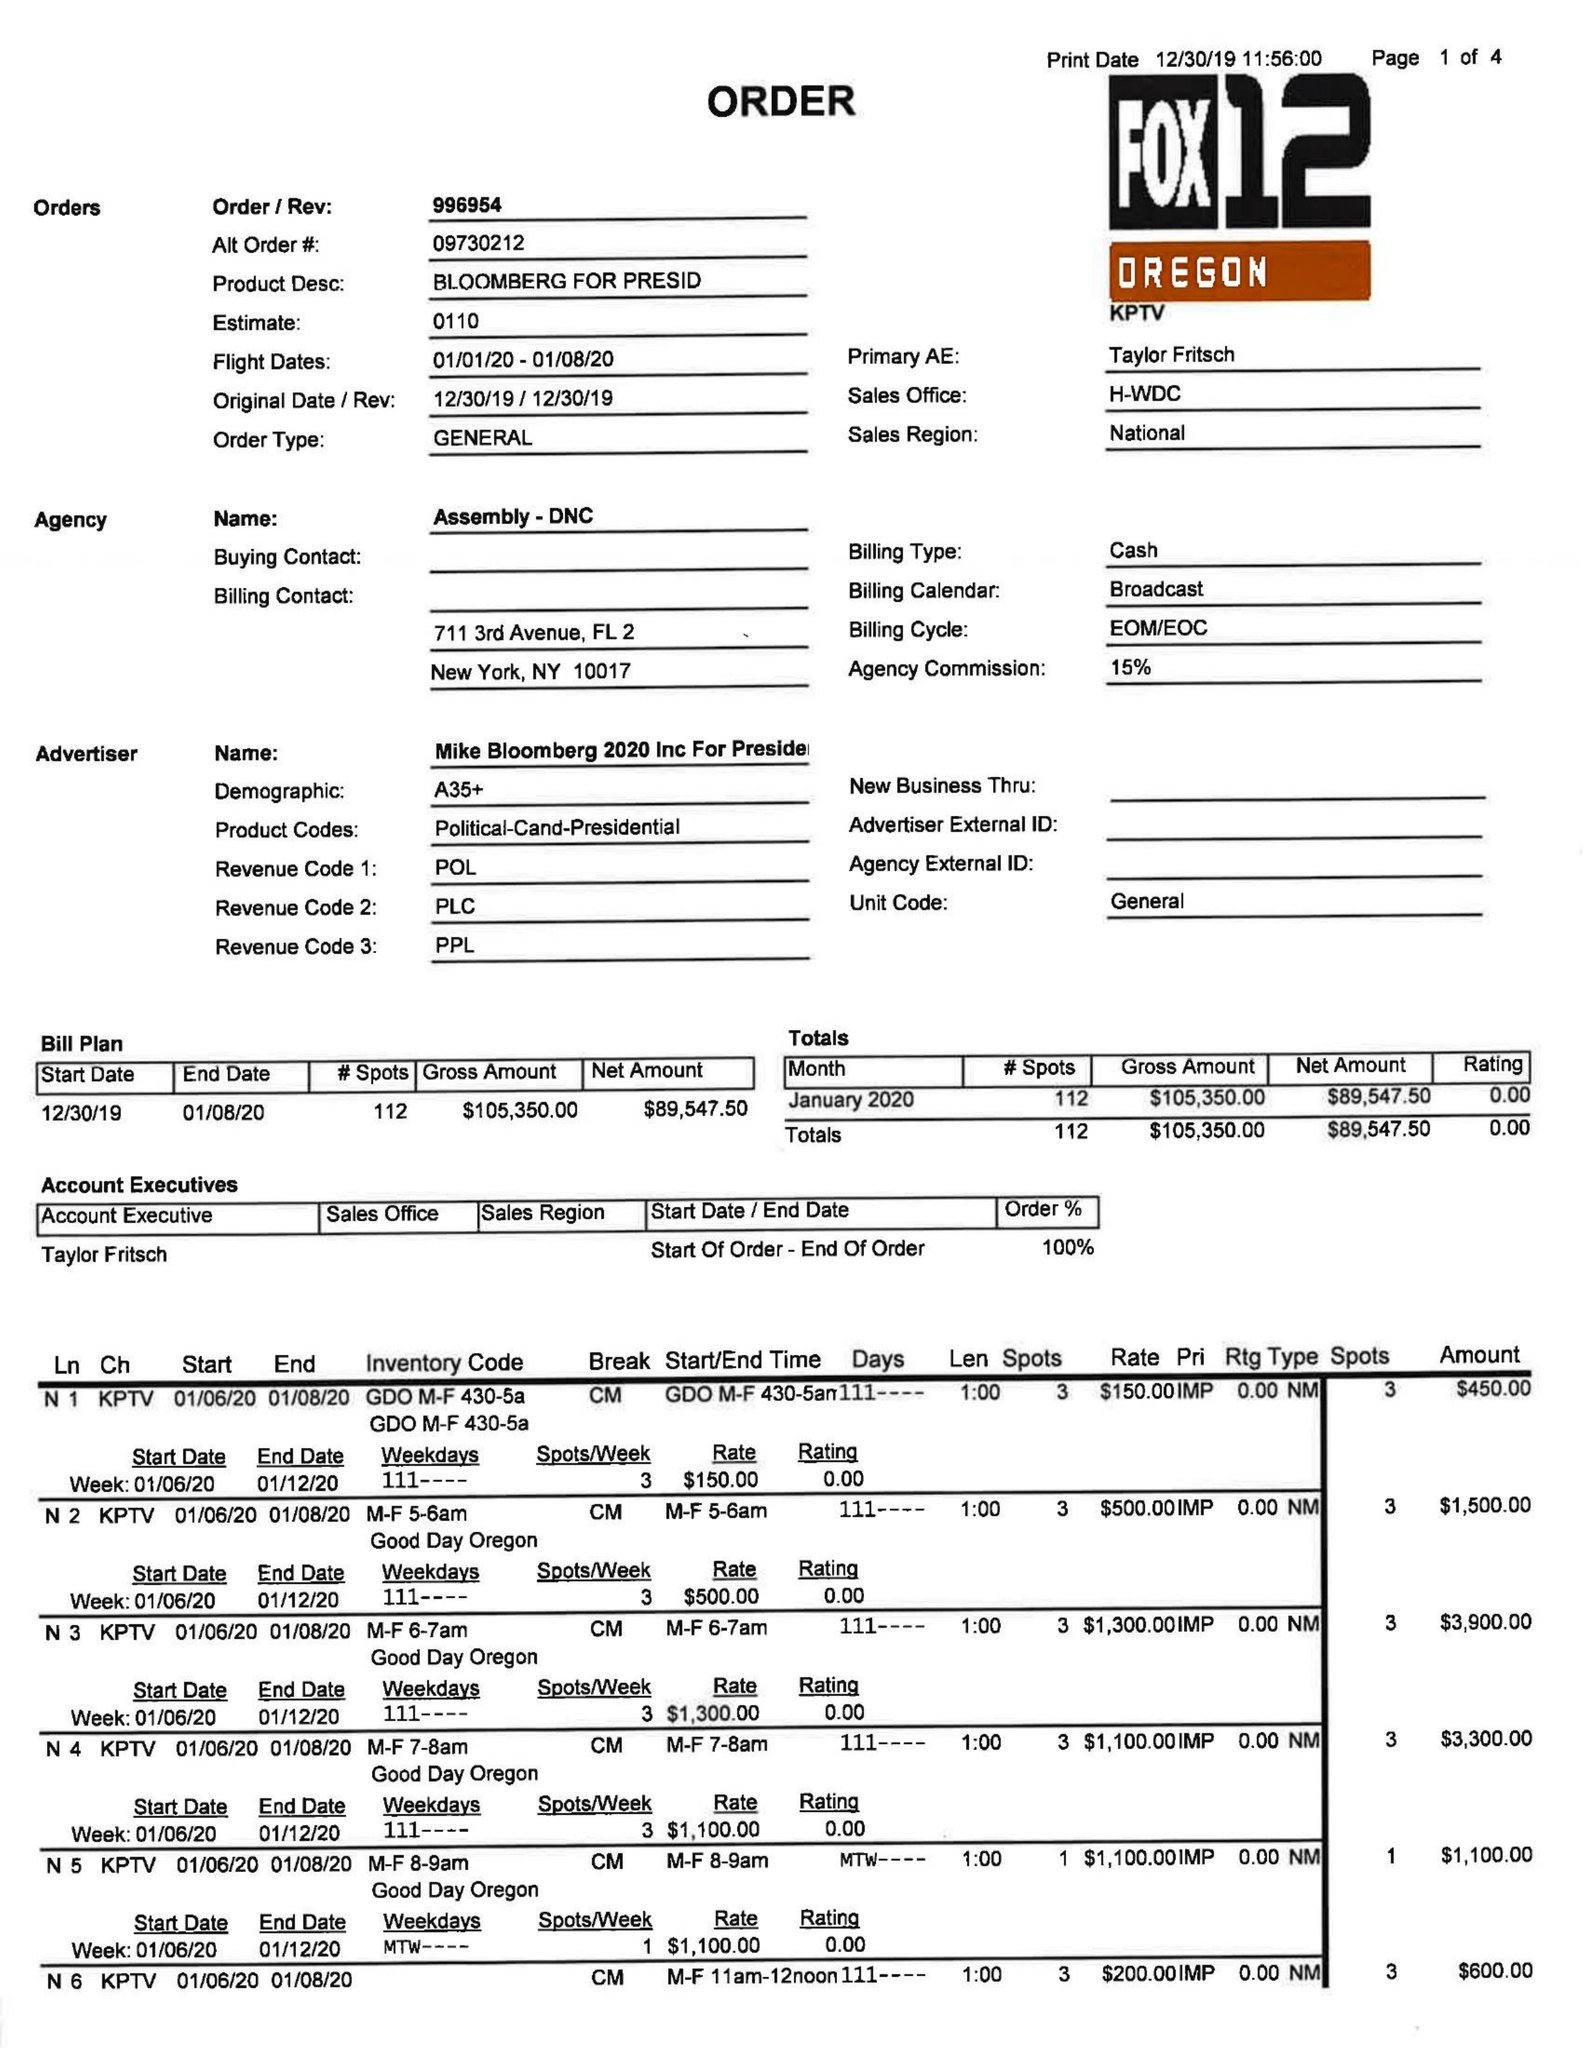What is the value for the advertiser?
Answer the question using a single word or phrase. MIKE BLOOMBERG 2020 INC FOR PRESIDENT 